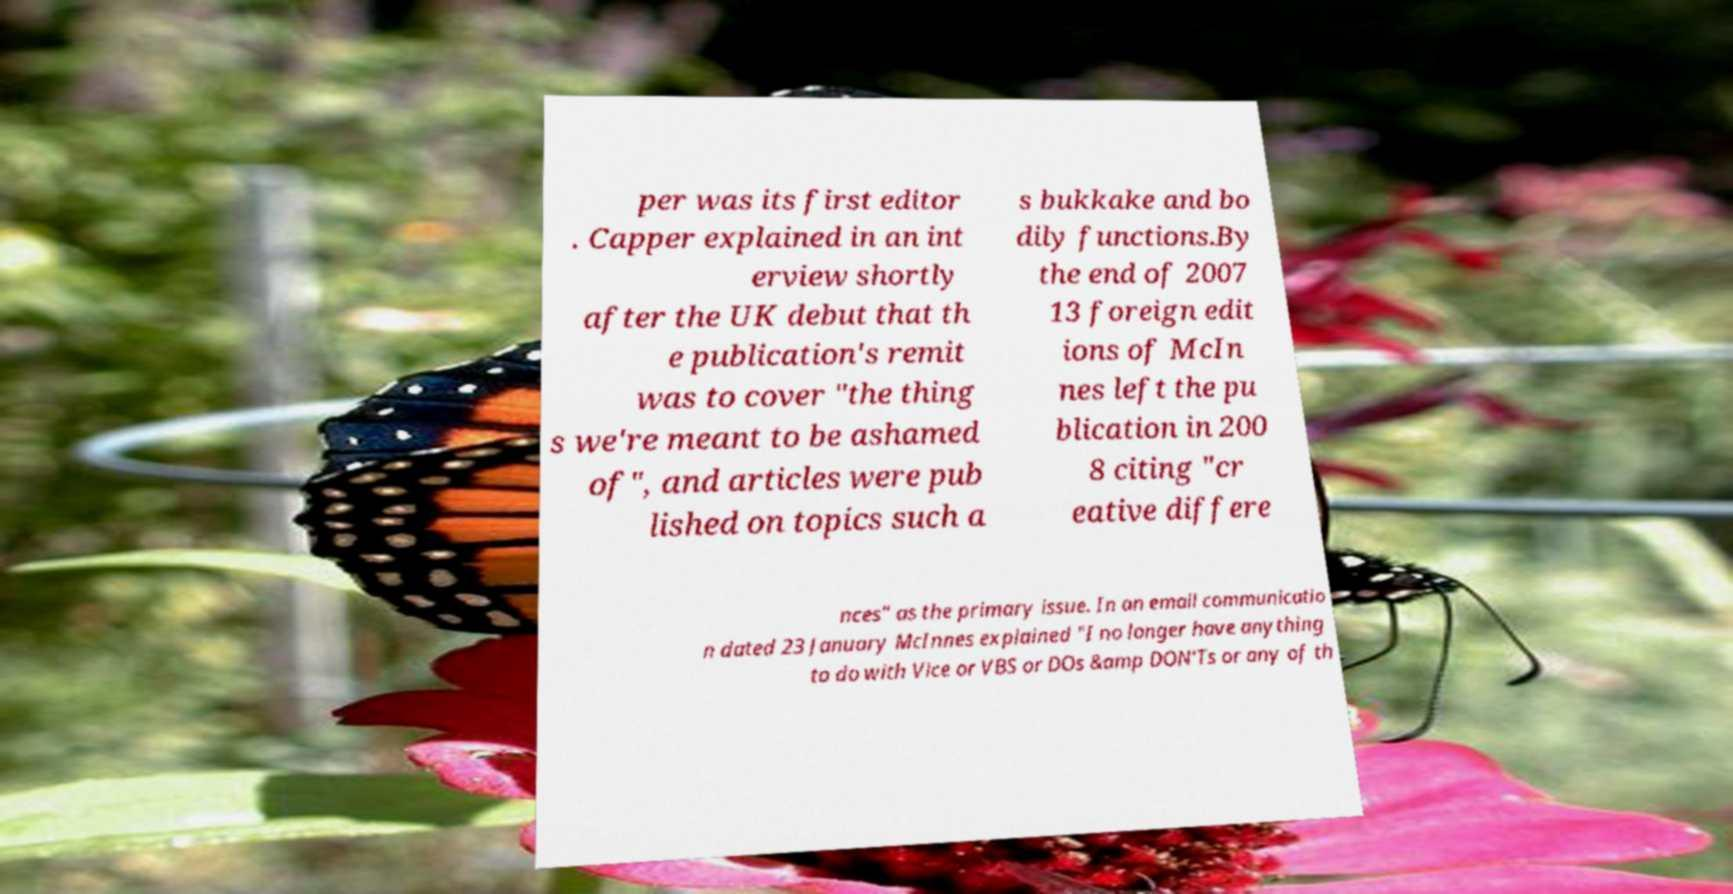Could you extract and type out the text from this image? per was its first editor . Capper explained in an int erview shortly after the UK debut that th e publication's remit was to cover "the thing s we're meant to be ashamed of", and articles were pub lished on topics such a s bukkake and bo dily functions.By the end of 2007 13 foreign edit ions of McIn nes left the pu blication in 200 8 citing "cr eative differe nces" as the primary issue. In an email communicatio n dated 23 January McInnes explained "I no longer have anything to do with Vice or VBS or DOs &amp DON'Ts or any of th 